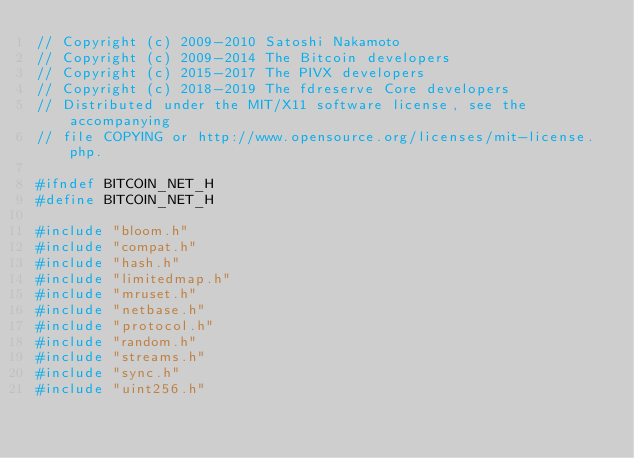<code> <loc_0><loc_0><loc_500><loc_500><_C_>// Copyright (c) 2009-2010 Satoshi Nakamoto
// Copyright (c) 2009-2014 The Bitcoin developers
// Copyright (c) 2015-2017 The PIVX developers
// Copyright (c) 2018-2019 The fdreserve Core developers
// Distributed under the MIT/X11 software license, see the accompanying
// file COPYING or http://www.opensource.org/licenses/mit-license.php.

#ifndef BITCOIN_NET_H
#define BITCOIN_NET_H

#include "bloom.h"
#include "compat.h"
#include "hash.h"
#include "limitedmap.h"
#include "mruset.h"
#include "netbase.h"
#include "protocol.h"
#include "random.h"
#include "streams.h"
#include "sync.h"
#include "uint256.h"</code> 